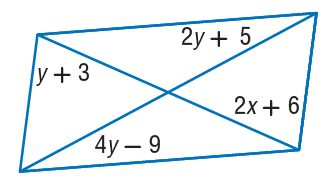Answer the mathemtical geometry problem and directly provide the correct option letter.
Question: Find x so that the quadrilateral is a parallelogram.
Choices: A: 2 B: 4 C: 10 D: 12 A 